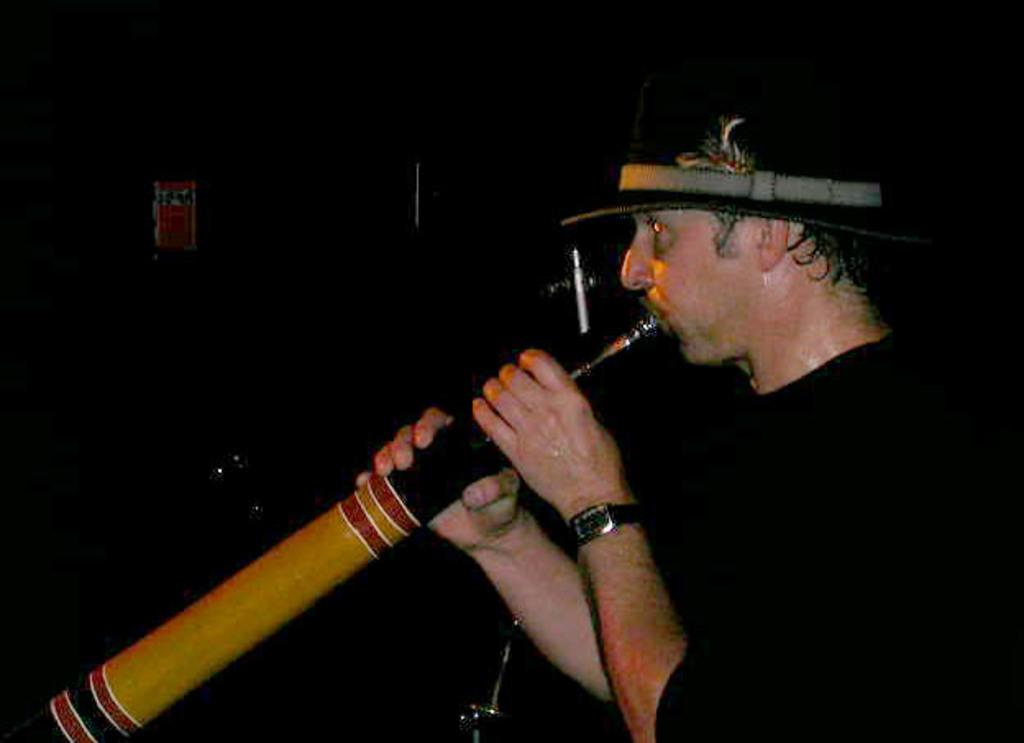Who is the main subject in the image? There is a man in the image. What is the man wearing? The man is wearing a black dress and a hat. What is the man doing in the image? The man is playing a musical instrument. What is the color of the background in the image? The background of the image is dark. What type of land can be seen in the background of the image? There is no land visible in the background of the image; it is dark. How many light bulbs are present in the image? There are no light bulbs present in the image. 